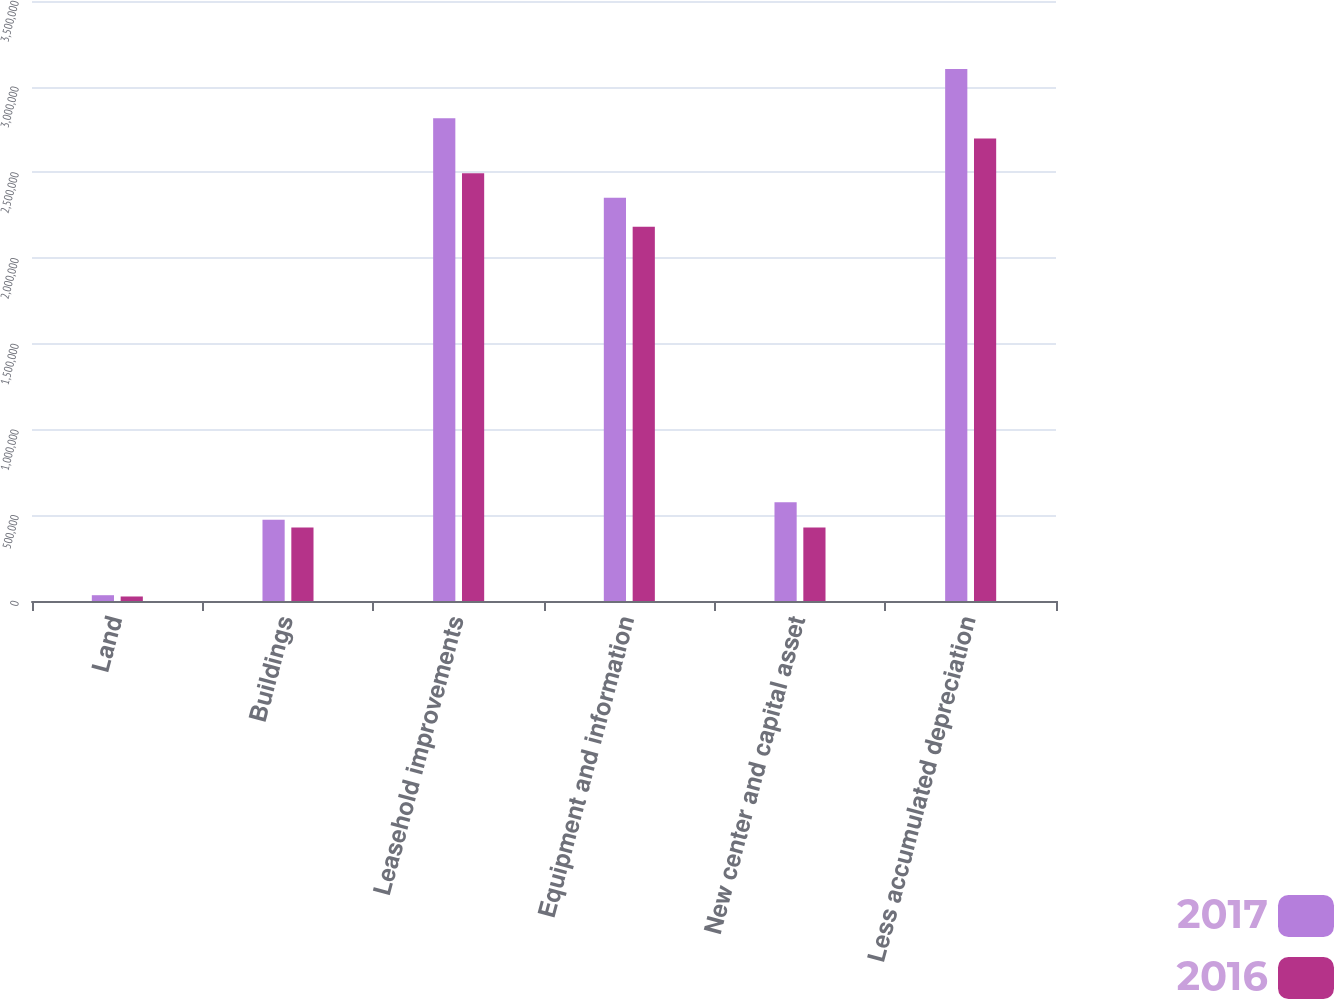<chart> <loc_0><loc_0><loc_500><loc_500><stacked_bar_chart><ecel><fcel>Land<fcel>Buildings<fcel>Leasehold improvements<fcel>Equipment and information<fcel>New center and capital asset<fcel>Less accumulated depreciation<nl><fcel>2017<fcel>33814<fcel>473489<fcel>2.81668e+06<fcel>2.35225e+06<fcel>576651<fcel>3.10366e+06<nl><fcel>2016<fcel>26339<fcel>429039<fcel>2.49507e+06<fcel>2.18291e+06<fcel>429037<fcel>2.69828e+06<nl></chart> 